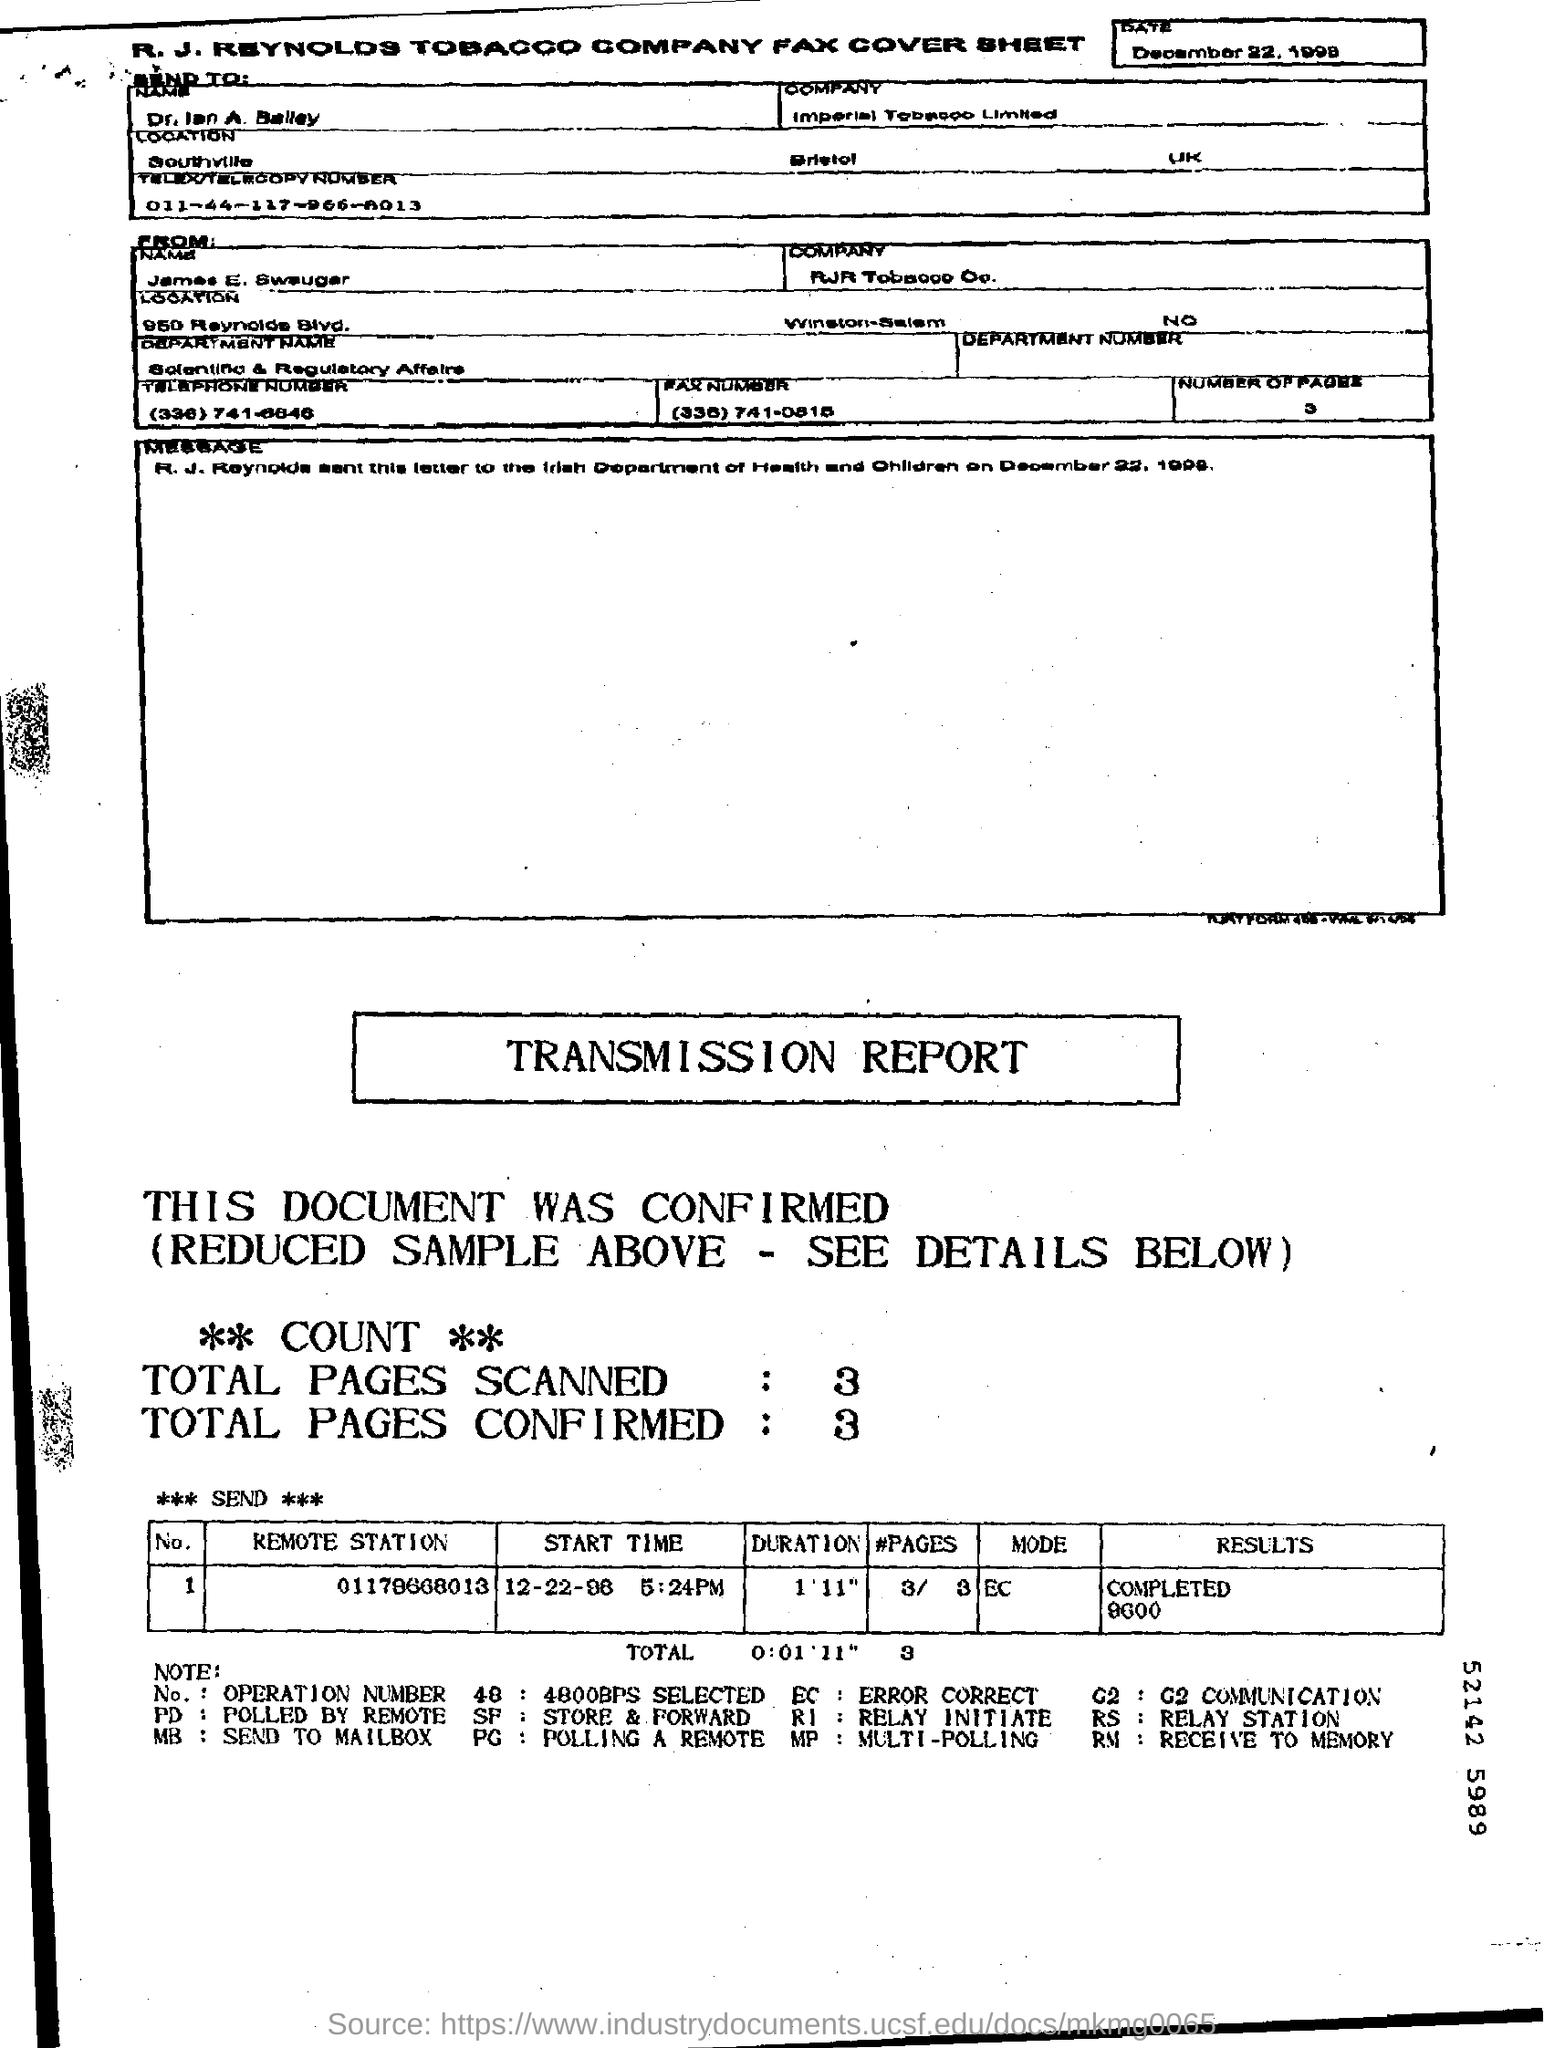Mention a couple of crucial points in this snapshot. The total number of pages confirmed in the transmission report is 3. The transmission report indicates that the transmission has been completed with a speed of 9600. The total number of pages scanned in the transmission report is 3. The mode mentioned in the transmission report is EC. 